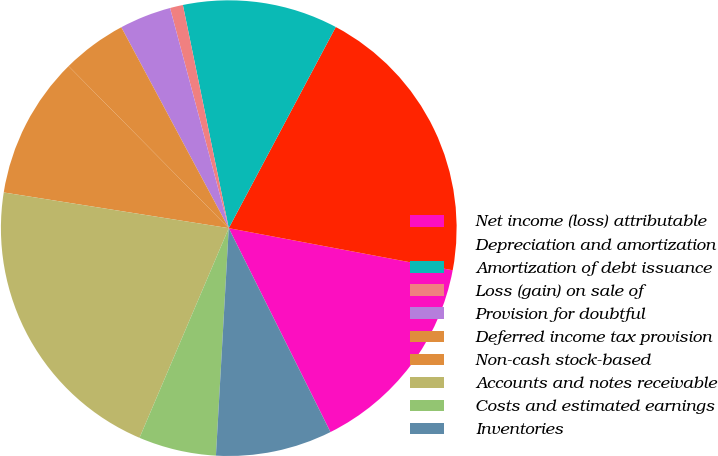Convert chart to OTSL. <chart><loc_0><loc_0><loc_500><loc_500><pie_chart><fcel>Net income (loss) attributable<fcel>Depreciation and amortization<fcel>Amortization of debt issuance<fcel>Loss (gain) on sale of<fcel>Provision for doubtful<fcel>Deferred income tax provision<fcel>Non-cash stock-based<fcel>Accounts and notes receivable<fcel>Costs and estimated earnings<fcel>Inventories<nl><fcel>14.68%<fcel>20.18%<fcel>11.01%<fcel>0.92%<fcel>3.67%<fcel>4.59%<fcel>10.09%<fcel>21.1%<fcel>5.51%<fcel>8.26%<nl></chart> 